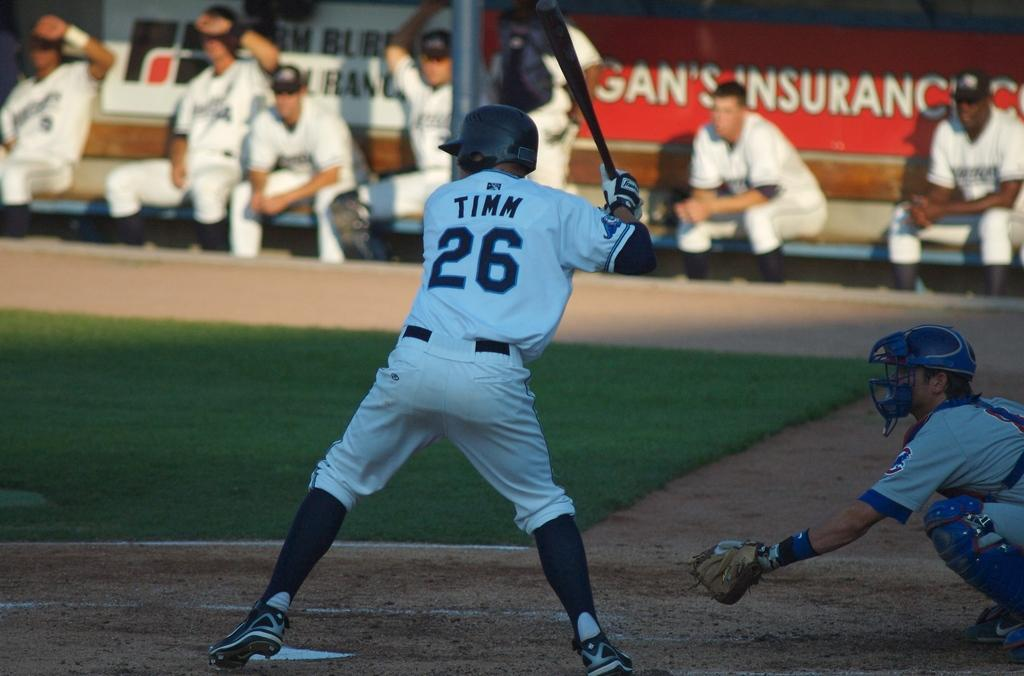Provide a one-sentence caption for the provided image. Tinn is up at bat at the baseball game. 